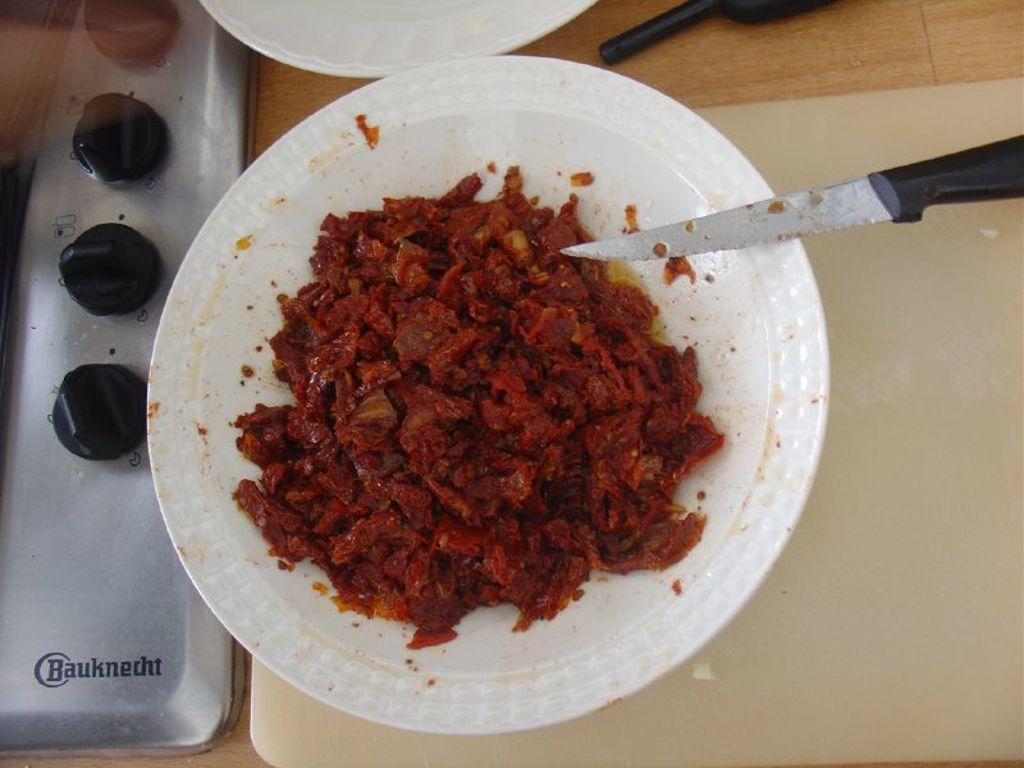What piece of furniture is in the image? There is a table in the image. What is on top of the table? A cutting board, a knife, two plates, and a stove are on the table. What is on one of the plates? There is food on one of the plates. Are there any other objects on the table? Yes, there are other objects on the table. What is the tax rate for the food on the plate in the image? There is no information about tax rates in the image, as it only shows a table with various objects and food on a plate. 